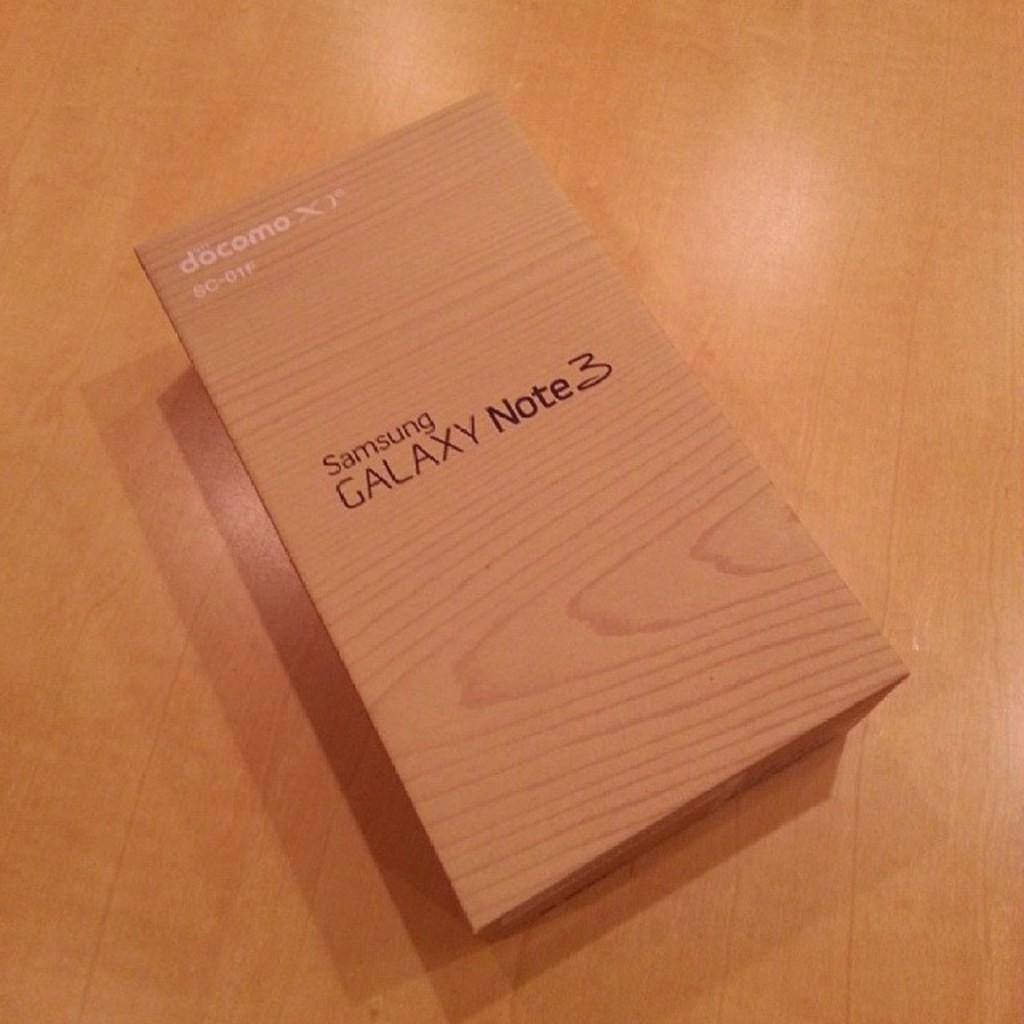<image>
Summarize the visual content of the image. A wooden box for a Samsung Galaxy Note 3 